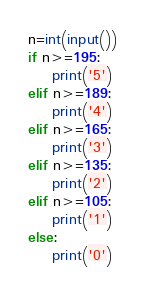Convert code to text. <code><loc_0><loc_0><loc_500><loc_500><_Python_>n=int(input())
if n>=195:
    print('5')
elif n>=189:
    print('4')
elif n>=165:
    print('3')
elif n>=135:
    print('2')
elif n>=105:
    print('1')
else:
    print('0')</code> 